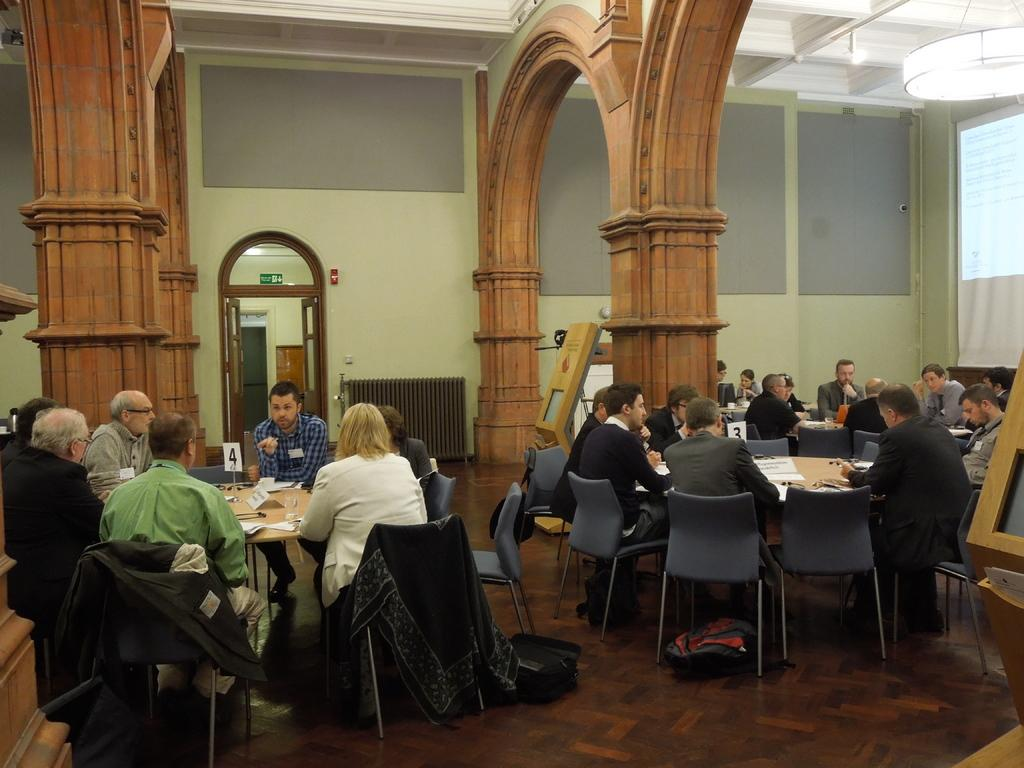How many people are in the image? There is a group of people in the image. What are the people doing in the image? The people are sitting in chairs. Where are the chairs located in relation to the tables? The chairs are near tables. What can be seen in the background of the image? There is a door, a hoarding, a light, and a screen in the background of the image. Can you see a crook holding a cord near the seashore in the image? There is no crook, cord, or seashore present in the image. 